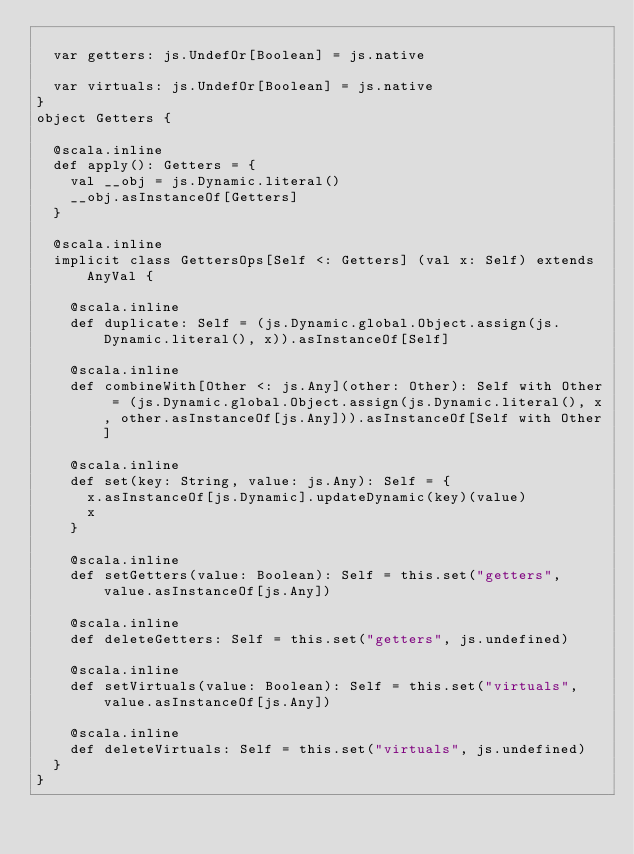Convert code to text. <code><loc_0><loc_0><loc_500><loc_500><_Scala_>  
  var getters: js.UndefOr[Boolean] = js.native
  
  var virtuals: js.UndefOr[Boolean] = js.native
}
object Getters {
  
  @scala.inline
  def apply(): Getters = {
    val __obj = js.Dynamic.literal()
    __obj.asInstanceOf[Getters]
  }
  
  @scala.inline
  implicit class GettersOps[Self <: Getters] (val x: Self) extends AnyVal {
    
    @scala.inline
    def duplicate: Self = (js.Dynamic.global.Object.assign(js.Dynamic.literal(), x)).asInstanceOf[Self]
    
    @scala.inline
    def combineWith[Other <: js.Any](other: Other): Self with Other = (js.Dynamic.global.Object.assign(js.Dynamic.literal(), x, other.asInstanceOf[js.Any])).asInstanceOf[Self with Other]
    
    @scala.inline
    def set(key: String, value: js.Any): Self = {
      x.asInstanceOf[js.Dynamic].updateDynamic(key)(value)
      x
    }
    
    @scala.inline
    def setGetters(value: Boolean): Self = this.set("getters", value.asInstanceOf[js.Any])
    
    @scala.inline
    def deleteGetters: Self = this.set("getters", js.undefined)
    
    @scala.inline
    def setVirtuals(value: Boolean): Self = this.set("virtuals", value.asInstanceOf[js.Any])
    
    @scala.inline
    def deleteVirtuals: Self = this.set("virtuals", js.undefined)
  }
}
</code> 